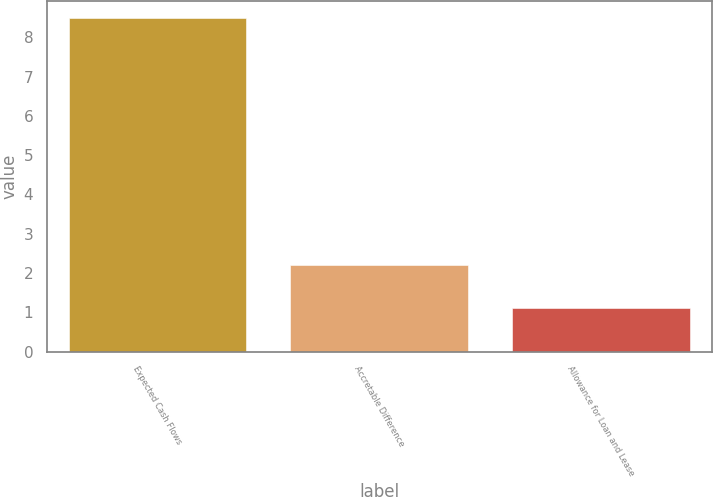<chart> <loc_0><loc_0><loc_500><loc_500><bar_chart><fcel>Expected Cash Flows<fcel>Accretable Difference<fcel>Allowance for Loan and Lease<nl><fcel>8.5<fcel>2.2<fcel>1.1<nl></chart> 